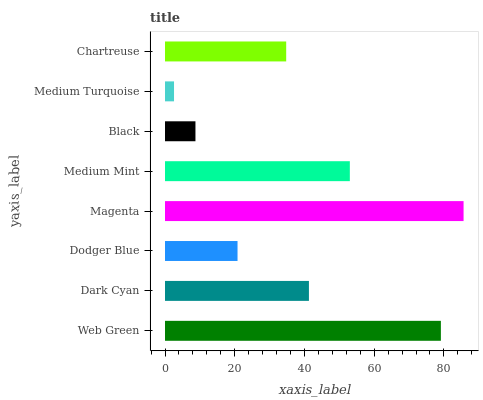Is Medium Turquoise the minimum?
Answer yes or no. Yes. Is Magenta the maximum?
Answer yes or no. Yes. Is Dark Cyan the minimum?
Answer yes or no. No. Is Dark Cyan the maximum?
Answer yes or no. No. Is Web Green greater than Dark Cyan?
Answer yes or no. Yes. Is Dark Cyan less than Web Green?
Answer yes or no. Yes. Is Dark Cyan greater than Web Green?
Answer yes or no. No. Is Web Green less than Dark Cyan?
Answer yes or no. No. Is Dark Cyan the high median?
Answer yes or no. Yes. Is Chartreuse the low median?
Answer yes or no. Yes. Is Dodger Blue the high median?
Answer yes or no. No. Is Web Green the low median?
Answer yes or no. No. 